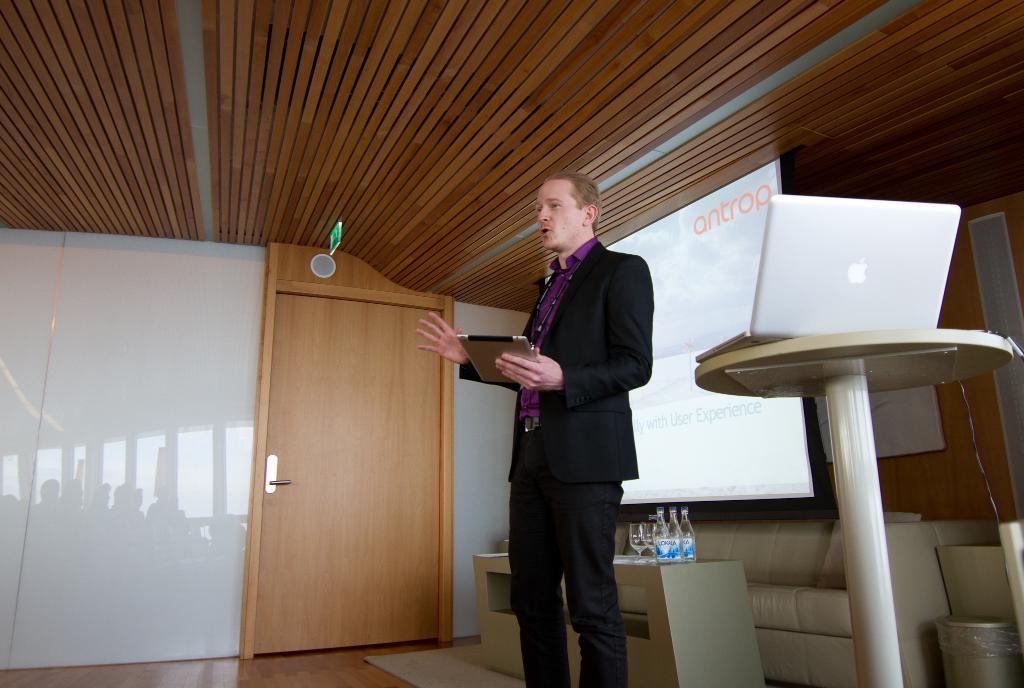Please provide a concise description of this image. In the center we can see one man standing and holding tab. In the back ground there is a board,table,laptop,bottles,glass,couch,door and wall. 